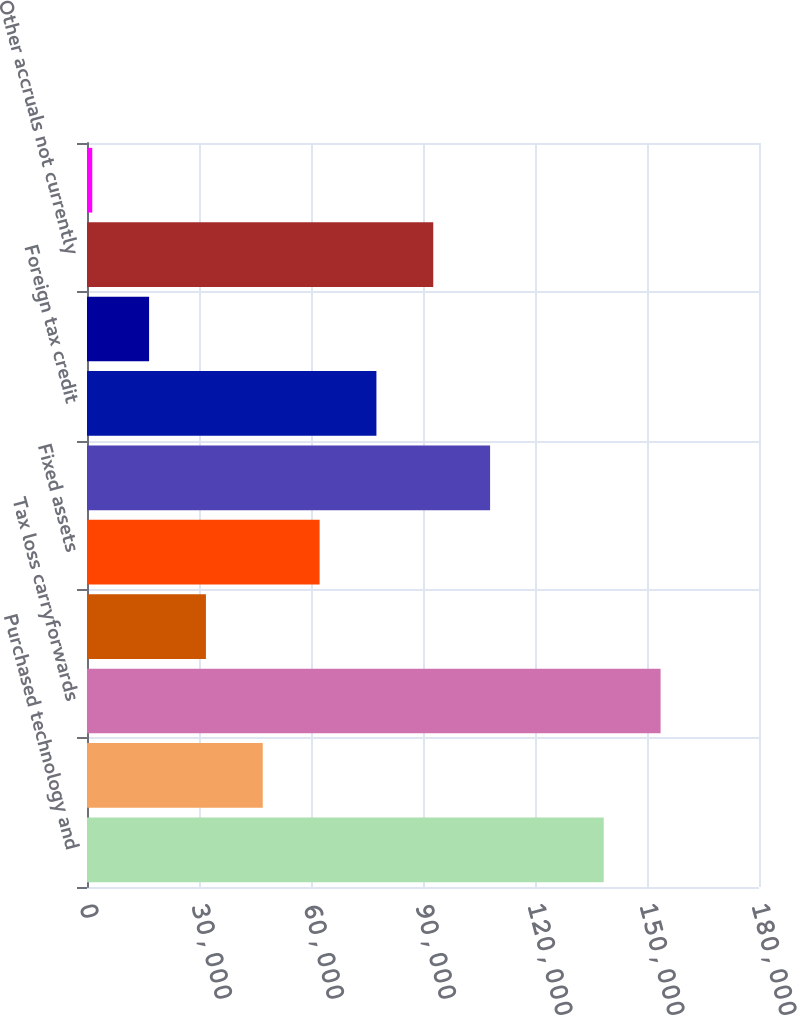Convert chart. <chart><loc_0><loc_0><loc_500><loc_500><bar_chart><fcel>Purchased technology and<fcel>Reserves for product returns<fcel>Tax loss carryforwards<fcel>Accrued compensation and<fcel>Fixed assets<fcel>Research and development<fcel>Foreign tax credit<fcel>Capitalized R&D expenditures<fcel>Other accruals not currently<fcel>Other<nl><fcel>138418<fcel>47077.9<fcel>153641<fcel>31854.6<fcel>62301.2<fcel>107971<fcel>77524.5<fcel>16631.3<fcel>92747.8<fcel>1408<nl></chart> 